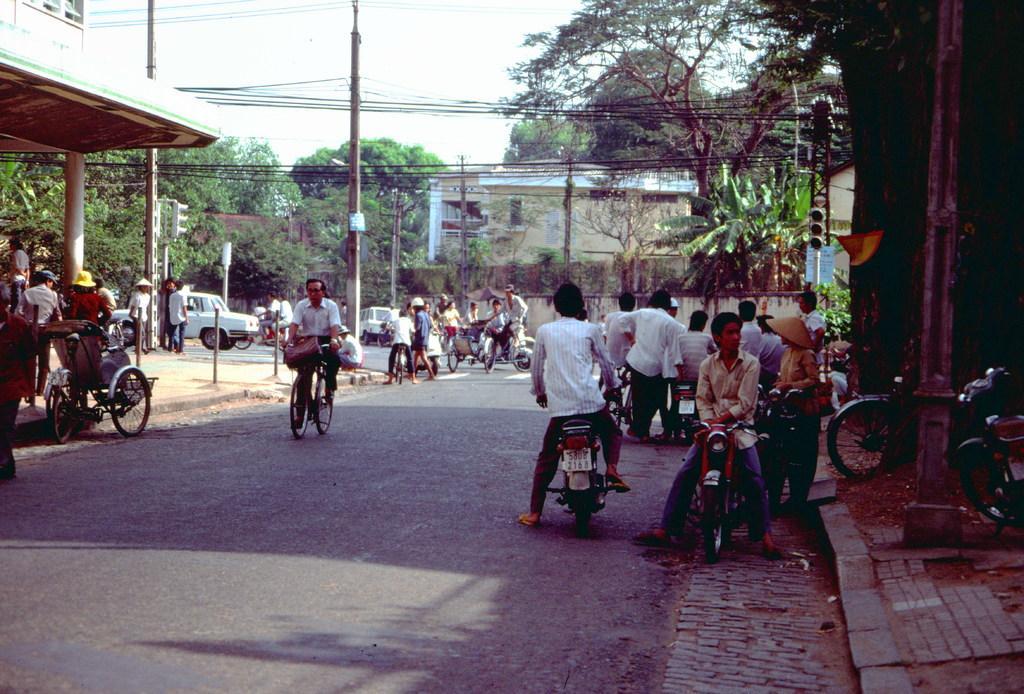Describe this image in one or two sentences. In this picture we can see vehicles on the road and some people are on these vehicles, some people are on the footpath, poles, trees, buildings, traffic signals and some objects and in the background we can see the sky. 